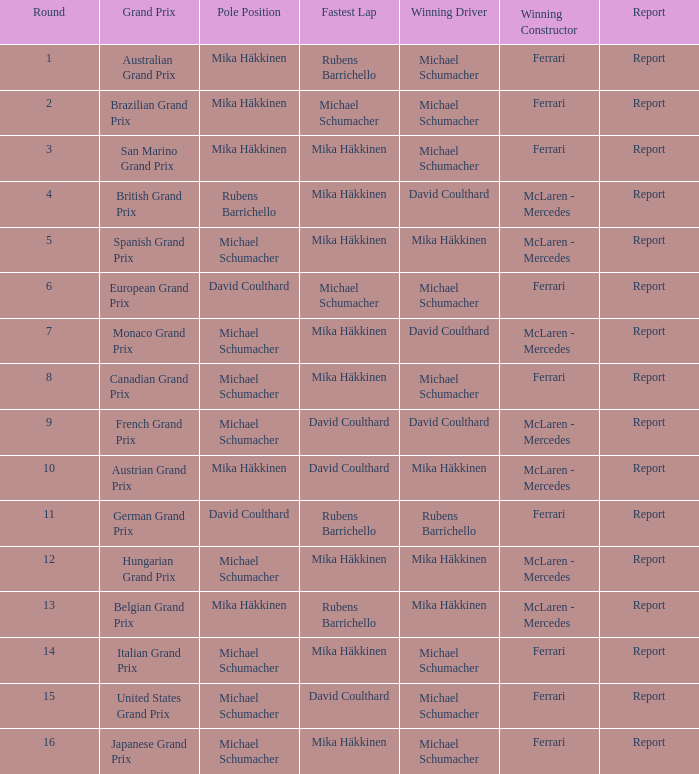How many individuals have been victorious in the italian grand prix? 1.0. Parse the table in full. {'header': ['Round', 'Grand Prix', 'Pole Position', 'Fastest Lap', 'Winning Driver', 'Winning Constructor', 'Report'], 'rows': [['1', 'Australian Grand Prix', 'Mika Häkkinen', 'Rubens Barrichello', 'Michael Schumacher', 'Ferrari', 'Report'], ['2', 'Brazilian Grand Prix', 'Mika Häkkinen', 'Michael Schumacher', 'Michael Schumacher', 'Ferrari', 'Report'], ['3', 'San Marino Grand Prix', 'Mika Häkkinen', 'Mika Häkkinen', 'Michael Schumacher', 'Ferrari', 'Report'], ['4', 'British Grand Prix', 'Rubens Barrichello', 'Mika Häkkinen', 'David Coulthard', 'McLaren - Mercedes', 'Report'], ['5', 'Spanish Grand Prix', 'Michael Schumacher', 'Mika Häkkinen', 'Mika Häkkinen', 'McLaren - Mercedes', 'Report'], ['6', 'European Grand Prix', 'David Coulthard', 'Michael Schumacher', 'Michael Schumacher', 'Ferrari', 'Report'], ['7', 'Monaco Grand Prix', 'Michael Schumacher', 'Mika Häkkinen', 'David Coulthard', 'McLaren - Mercedes', 'Report'], ['8', 'Canadian Grand Prix', 'Michael Schumacher', 'Mika Häkkinen', 'Michael Schumacher', 'Ferrari', 'Report'], ['9', 'French Grand Prix', 'Michael Schumacher', 'David Coulthard', 'David Coulthard', 'McLaren - Mercedes', 'Report'], ['10', 'Austrian Grand Prix', 'Mika Häkkinen', 'David Coulthard', 'Mika Häkkinen', 'McLaren - Mercedes', 'Report'], ['11', 'German Grand Prix', 'David Coulthard', 'Rubens Barrichello', 'Rubens Barrichello', 'Ferrari', 'Report'], ['12', 'Hungarian Grand Prix', 'Michael Schumacher', 'Mika Häkkinen', 'Mika Häkkinen', 'McLaren - Mercedes', 'Report'], ['13', 'Belgian Grand Prix', 'Mika Häkkinen', 'Rubens Barrichello', 'Mika Häkkinen', 'McLaren - Mercedes', 'Report'], ['14', 'Italian Grand Prix', 'Michael Schumacher', 'Mika Häkkinen', 'Michael Schumacher', 'Ferrari', 'Report'], ['15', 'United States Grand Prix', 'Michael Schumacher', 'David Coulthard', 'Michael Schumacher', 'Ferrari', 'Report'], ['16', 'Japanese Grand Prix', 'Michael Schumacher', 'Mika Häkkinen', 'Michael Schumacher', 'Ferrari', 'Report']]} 